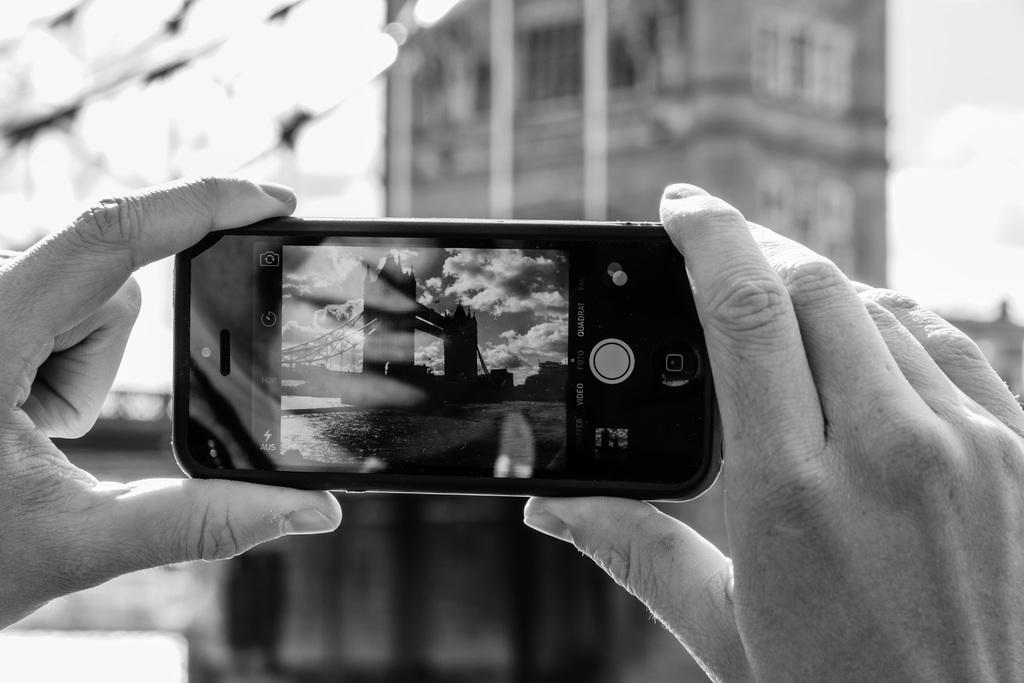What object is being held by both hands in the image? There is a smartphone in the image, and it is held by both hands. What can be seen in the background of the image? There is a building in the background of the image. What is the condition of the sky in the image? The sky is cloudy in the image. What natural feature is visible in the image? There is a water body visible in the image. What type of apple is being eaten by the doll in the image? There is no apple or doll present in the image. What expression does the doll have on its face in the image? There is no doll present in the image, so it is not possible to determine its expression. 